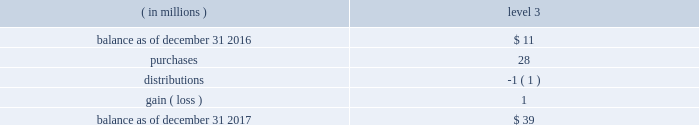For securities that are quoted in active markets , the trustee/ custodian determines fair value by applying securities 2019 prices obtained from its pricing vendors .
For commingled funds that are not actively traded , the trustee applies pricing information provided by investment management firms to the unit quanti- ties of such funds .
Investment management firms employ their own pricing vendors to value the securities underlying each commingled fund .
Underlying securities that are not actively traded derive their prices from investment managers , which in turn , employ vendors that use pricing models ( e.g. , discounted cash flow , comparables ) .
The domestic defined benefit plans have no investment in our stock , except through the s&p 500 commingled trust index fund .
The trustee obtains estimated prices from vendors for secu- rities that are not easily quotable and they are categorized accordingly as level 3 .
The table details further information on our plan assets where we have used significant unobservable inputs ( level 3 ) : .
Pension trusts 2019 asset allocations there are two pension trusts , one in the u.s .
And one in the u.k .
The u.s .
Pension trust had assets of $ 1739 a0 million and $ 1632 a0million as of december a031 , 2017 and 2016 respectively , and the target allocations in 2017 include 68% ( 68 % ) fixed income , 27% ( 27 % ) domestic equities and 5% ( 5 % ) international equities .
The u.k .
Pension trust had assets of $ 480 a0 million and $ 441 a0 million as of december a0 31 , 2017 and 2016 , respec- tively , and the target allocations in 2017 include 40% ( 40 % ) fixed income , 30% ( 30 % ) diversified growth funds , 20% ( 20 % ) equities and 10% ( 10 % ) real estate .
The pension assets are invested with the goal of producing a combination of capital growth , income and a liability hedge .
The mix of assets is established after consideration of the long- term performance and risk characteristics of asset classes .
Investments are selected based on their potential to enhance returns , preserve capital and reduce overall volatility .
Holdings are diversified within each asset class .
The portfolios employ a mix of index and actively managed equity strategies by market capitalization , style , geographic regions and economic sec- tors .
The fixed income strategies include u.s .
Long duration securities , opportunistic fixed income securities and u.k .
Debt instruments .
The short-term portfolio , whose primary goal is capital preservation for liquidity purposes , is composed of gov- ernment and government- agency securities , uninvested cash , receivables and payables .
The portfolios do not employ any financial leverage .
U.s .
Defined contribution plans assets of the defined contribution plans in the u.s .
Consist pri- marily of investment options which include actively managed equity , indexed equity , actively managed equity/bond funds , target date funds , s&p global inc .
Common stock , stable value and money market strategies .
There is also a self- directed mutual fund investment option .
The plans purchased 228248 shares and sold 297750 shares of s&p global inc .
Common stock in 2017 and purchased 216035 shares and sold 437283 shares of s&p global inc .
Common stock in 2016 .
The plans held approximately 1.5 a0million shares of s&p global inc .
Com- mon stock as of december a031 , 2017 and 1.6 a0million shares as of december a031 , 2016 , with market values of $ 255 a0million and $ 171 a0million , respectively .
The plans received dividends on s&p global inc .
Common stock of $ 3 a0million and $ 2 a0million during the years ended december a031 , 2017 and december a031 , 2016 respectively .
Stock-based compensation we issue stock-based incentive awards to our eligible employ- ees and directors under the 2002 employee stock incentive plan and a director deferred stock ownership plan .
2002 employee stock incentive plan ( the 201c2002 plan 201d ) 2014 the 2002 plan permits the granting of nonquali- fied stock options , stock appreciation rights , performance stock , restricted stock and other stock-based awards .
Director deferred stock ownership plan 2014 under this plan , common stock reserved may be credited to deferred stock accounts for eligible directors .
In general , the plan requires that 50% ( 50 % ) of eligible directors 2019 annual com- pensation plus dividend equivalents be credited to deferred stock accounts .
Each director may also elect to defer all or a portion of the remaining compensation and have an equiva- lent number of shares credited to the deferred stock account .
Recipients under this plan are not required to provide con- sideration to us other than rendering service .
Shares will be delivered as of the date a recipient ceases to be a member of the board of directors or within five years thereafter , if so elected .
The plan will remain in effect until terminated by the board of directors or until no shares of stock remain avail- able under the plan .
S&p global 2017 annual report 71 .
As part of plan assets what was the percent of the purchases on the total account balance? 
Rationale: as part of plan assets the percent of the purchases on the total account balance was 71.8%
Computations: (28 / 39)
Answer: 0.71795. 